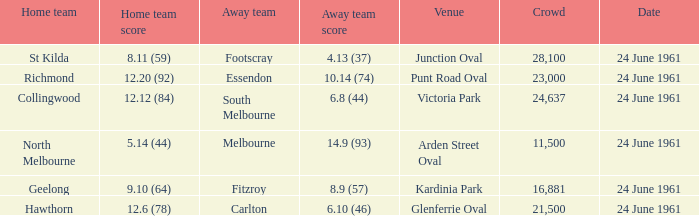What is the date of the game where the home team scored 9.10 (64)? 24 June 1961. 